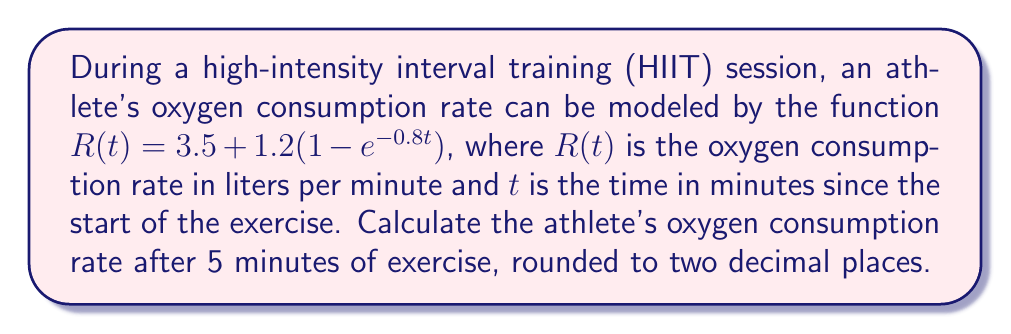What is the answer to this math problem? To solve this problem, we'll follow these steps:

1. Identify the given function:
   $R(t) = 3.5 + 1.2(1 - e^{-0.8t})$

2. Substitute $t = 5$ into the function:
   $R(5) = 3.5 + 1.2(1 - e^{-0.8(5)})$

3. Simplify the exponent:
   $R(5) = 3.5 + 1.2(1 - e^{-4})$

4. Calculate $e^{-4}$ using a calculator:
   $e^{-4} \approx 0.0183$

5. Substitute this value back into the equation:
   $R(5) = 3.5 + 1.2(1 - 0.0183)$

6. Simplify the expression inside the parentheses:
   $R(5) = 3.5 + 1.2(0.9817)$

7. Multiply:
   $R(5) = 3.5 + 1.1780$

8. Add:
   $R(5) = 4.6780$

9. Round to two decimal places:
   $R(5) \approx 4.68$

Therefore, after 5 minutes of exercise, the athlete's oxygen consumption rate is approximately 4.68 liters per minute.
Answer: 4.68 L/min 